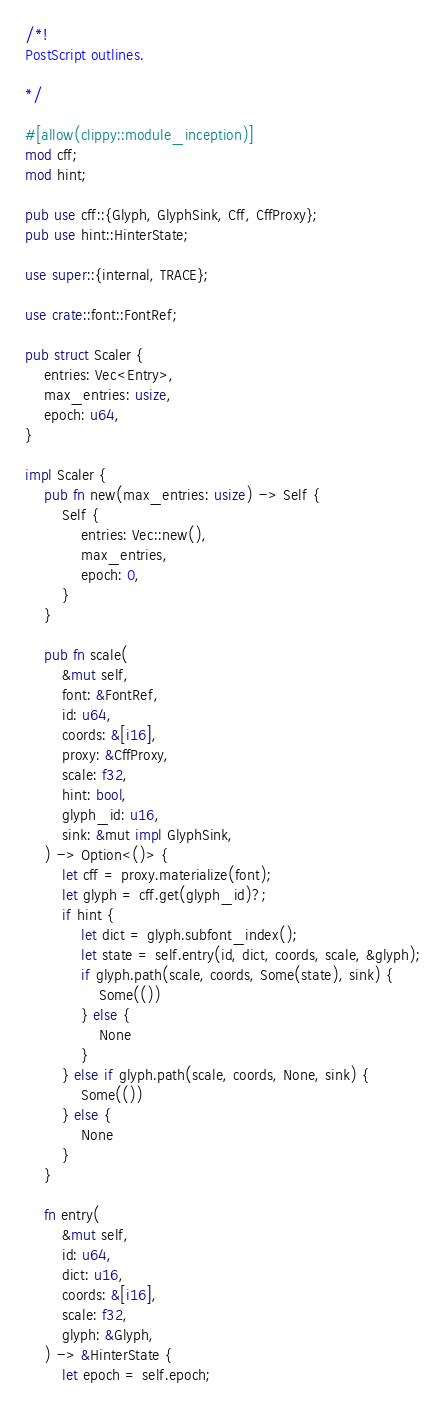Convert code to text. <code><loc_0><loc_0><loc_500><loc_500><_Rust_>/*!
PostScript outlines.

*/

#[allow(clippy::module_inception)]
mod cff;
mod hint;

pub use cff::{Glyph, GlyphSink, Cff, CffProxy};
pub use hint::HinterState;

use super::{internal, TRACE};

use crate::font::FontRef;

pub struct Scaler {
    entries: Vec<Entry>,
    max_entries: usize,
    epoch: u64,
}

impl Scaler {
    pub fn new(max_entries: usize) -> Self {
        Self {
            entries: Vec::new(),
            max_entries,
            epoch: 0,
        }
    }

    pub fn scale(
        &mut self,
        font: &FontRef,
        id: u64,
        coords: &[i16],
        proxy: &CffProxy,
        scale: f32,
        hint: bool,
        glyph_id: u16,
        sink: &mut impl GlyphSink,
    ) -> Option<()> {
        let cff = proxy.materialize(font);
        let glyph = cff.get(glyph_id)?;
        if hint {
            let dict = glyph.subfont_index();
            let state = self.entry(id, dict, coords, scale, &glyph);
            if glyph.path(scale, coords, Some(state), sink) {
                Some(())
            } else {
                None
            }
        } else if glyph.path(scale, coords, None, sink) {
            Some(())
        } else {
            None
        }
    }

    fn entry(
        &mut self,
        id: u64,
        dict: u16,
        coords: &[i16],
        scale: f32,
        glyph: &Glyph,
    ) -> &HinterState {
        let epoch = self.epoch;</code> 